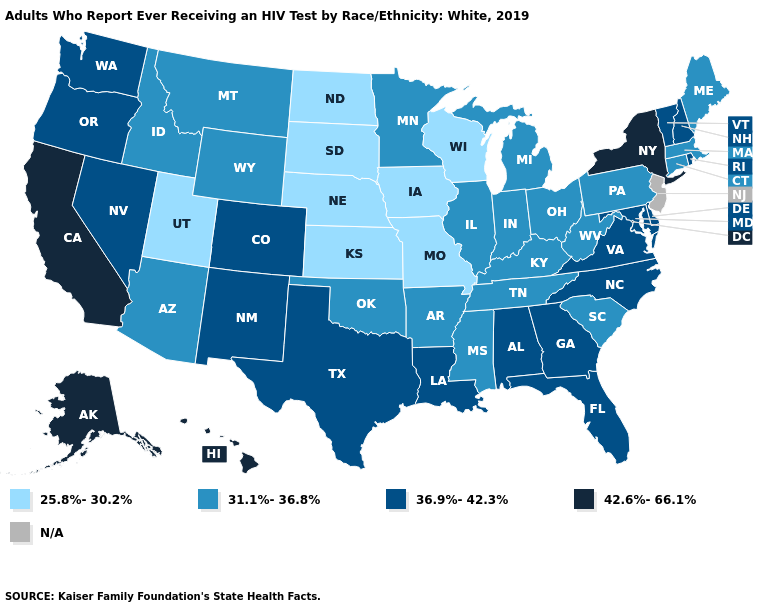Does Ohio have the lowest value in the USA?
Write a very short answer. No. Does Washington have the highest value in the West?
Be succinct. No. Does Missouri have the lowest value in the USA?
Keep it brief. Yes. What is the value of Arkansas?
Concise answer only. 31.1%-36.8%. Among the states that border South Dakota , which have the lowest value?
Be succinct. Iowa, Nebraska, North Dakota. How many symbols are there in the legend?
Be succinct. 5. What is the lowest value in the USA?
Be succinct. 25.8%-30.2%. Among the states that border Vermont , which have the highest value?
Keep it brief. New York. What is the value of Arizona?
Short answer required. 31.1%-36.8%. Name the states that have a value in the range 25.8%-30.2%?
Short answer required. Iowa, Kansas, Missouri, Nebraska, North Dakota, South Dakota, Utah, Wisconsin. What is the value of New Mexico?
Be succinct. 36.9%-42.3%. Name the states that have a value in the range 25.8%-30.2%?
Concise answer only. Iowa, Kansas, Missouri, Nebraska, North Dakota, South Dakota, Utah, Wisconsin. What is the lowest value in the West?
Write a very short answer. 25.8%-30.2%. 